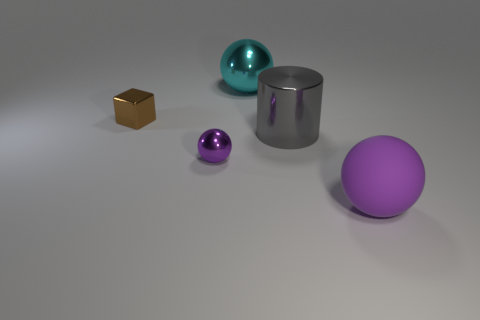Is the large rubber sphere the same color as the big shiny cylinder?
Give a very brief answer. No. Are there any cylinders of the same color as the rubber thing?
Make the answer very short. No. What is the color of the cylinder that is the same size as the matte thing?
Offer a terse response. Gray. Is there a purple metallic thing that has the same shape as the gray object?
Offer a terse response. No. There is a tiny object that is on the right side of the tiny shiny thing behind the purple metal object; are there any small metallic balls that are on the right side of it?
Give a very brief answer. No. The gray shiny thing that is the same size as the matte object is what shape?
Your answer should be compact. Cylinder. What color is the other big thing that is the same shape as the large purple rubber object?
Make the answer very short. Cyan. What number of objects are large green rubber things or big gray shiny objects?
Your answer should be very brief. 1. Does the small object that is behind the large gray cylinder have the same shape as the cyan object left of the big gray shiny cylinder?
Your answer should be very brief. No. What is the shape of the thing on the left side of the tiny purple thing?
Keep it short and to the point. Cube. 